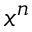Convert formula to latex. <formula><loc_0><loc_0><loc_500><loc_500>x ^ { n }</formula> 